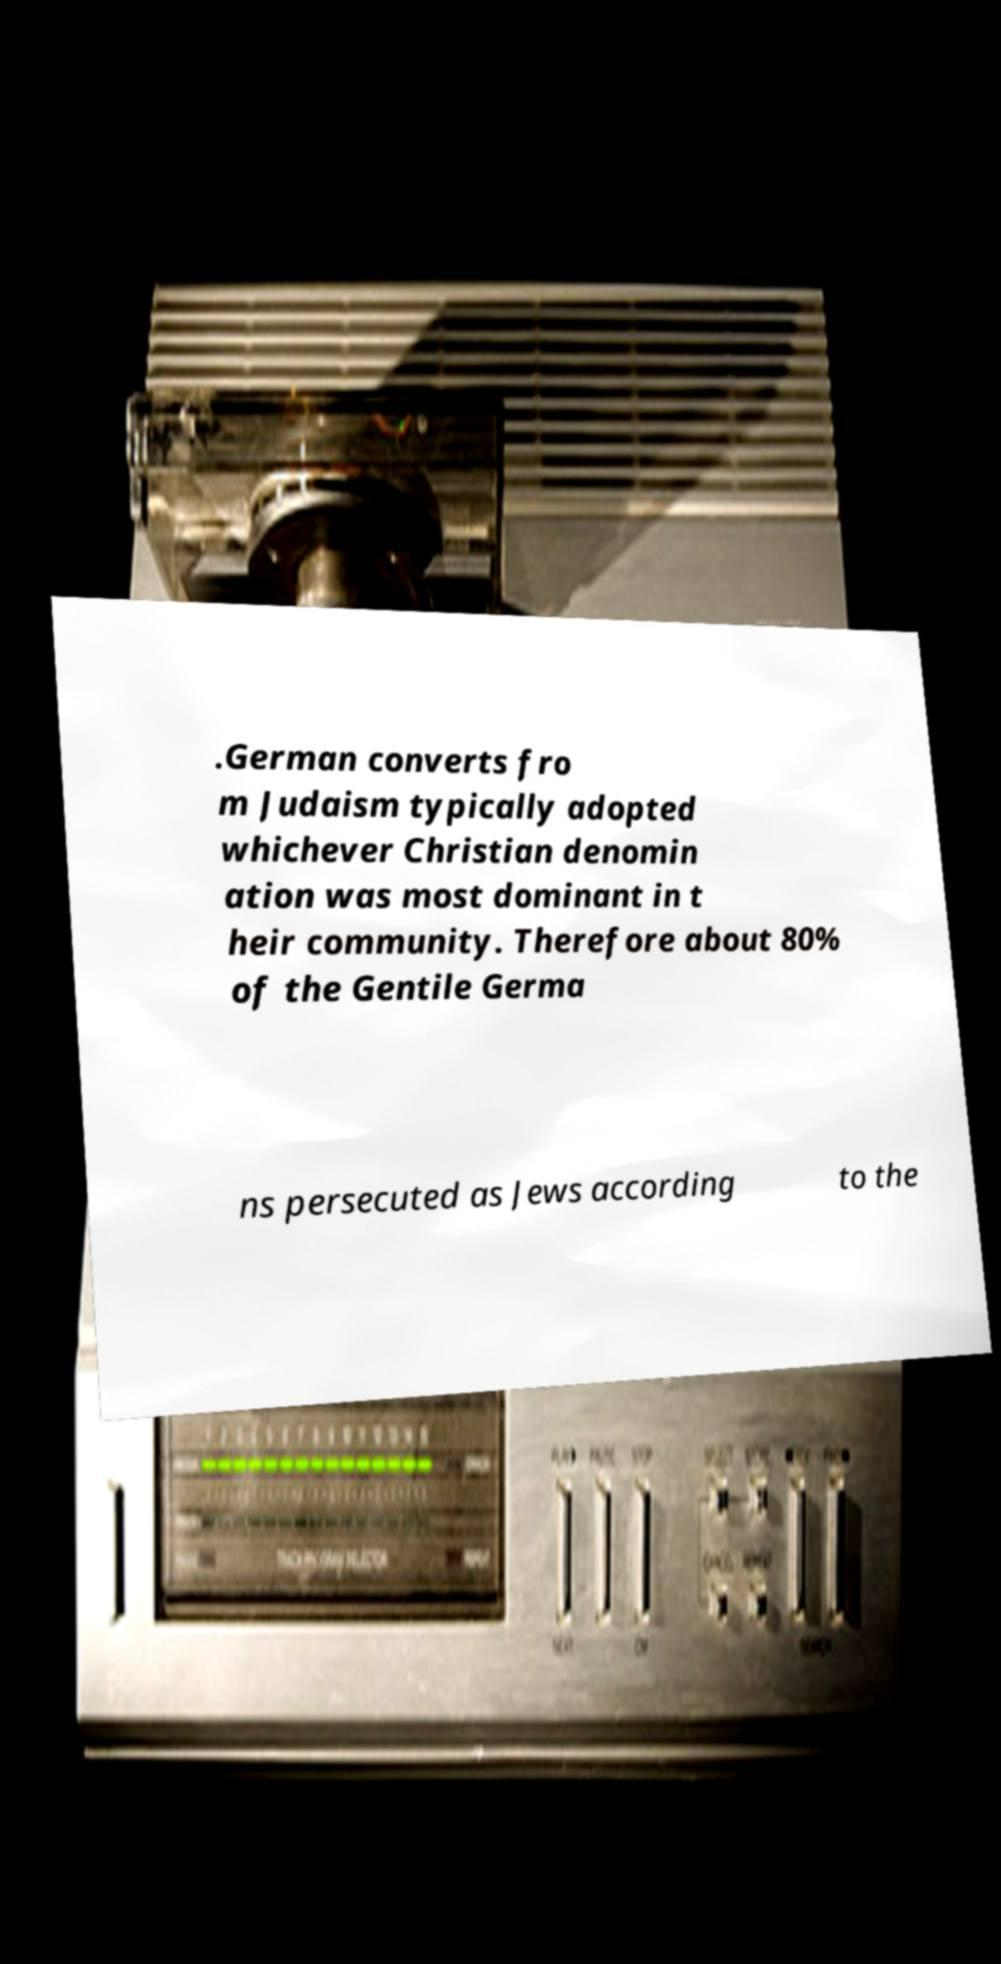Could you assist in decoding the text presented in this image and type it out clearly? .German converts fro m Judaism typically adopted whichever Christian denomin ation was most dominant in t heir community. Therefore about 80% of the Gentile Germa ns persecuted as Jews according to the 